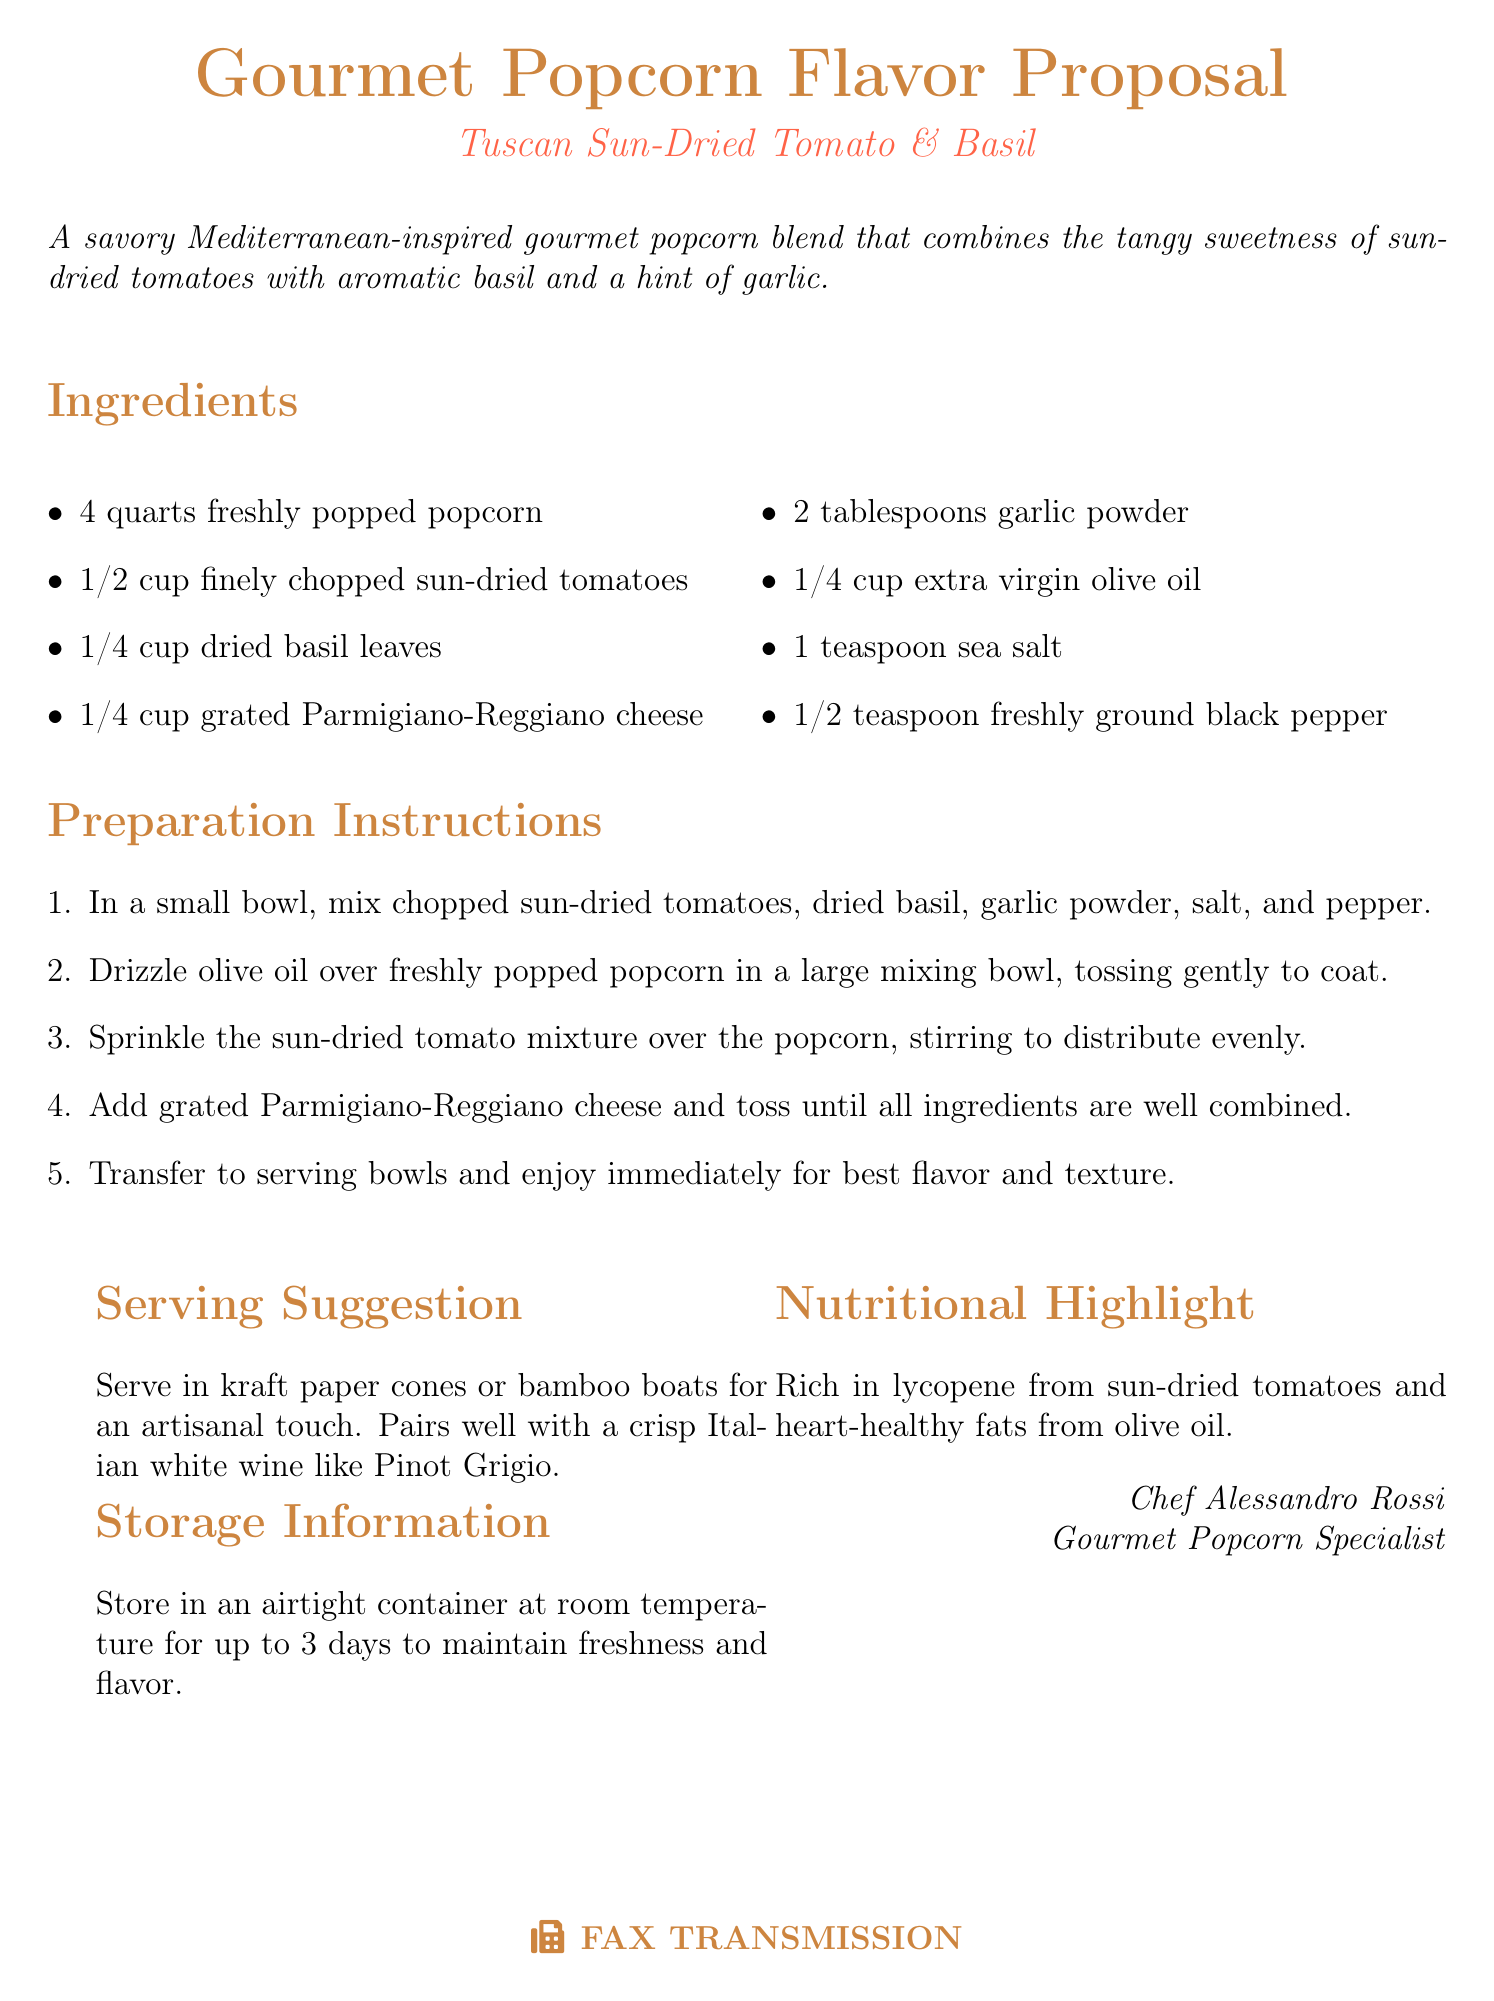What is the name of the new gourmet popcorn flavor? The name of the new gourmet popcorn flavor is mentioned at the top of the document, "Tuscan Sun-Dried Tomato & Basil."
Answer: Tuscan Sun-Dried Tomato & Basil How much finely chopped sun-dried tomatoes is needed? The amount of finely chopped sun-dried tomatoes required is listed in the ingredients section.
Answer: 1/2 cup What type of cheese is used in this recipe? The type of cheese mentioned in the ingredient list is specifically stated in the document.
Answer: Parmigiano-Reggiano cheese What is the recommended wine pairing? The recommended wine pairing is given in the serving suggestion section of the document.
Answer: Pinot Grigio How long can the popcorn be stored at room temperature? The storage information section specifies how long the popcorn can be stored.
Answer: 3 days What is the preparation step that involves olive oil? The preparation instructions outline the role of olive oil in a specific step.
Answer: Drizzle olive oil over freshly popped popcorn What is rich in lycopene according to the nutritional highlight? The nutritional highlight notes what ingredient is rich in lycopene.
Answer: Sun-dried tomatoes Who is the chef mentioned in the document? The document includes a signature with the chef's name.
Answer: Chef Alessandro Rossi What is the total number of ingredients listed? The ingredients section contains a list of components; counting them provides the total.
Answer: 8 